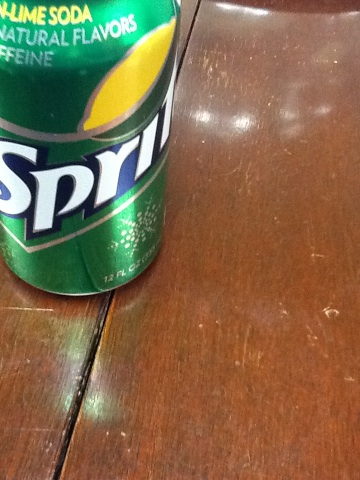What does the text on the can indicate about the product's features? The text on the can indicates that this Sprite is a lime-flavored soda with natural flavors. It also suggests an energizing aspect with the mention of caffeine, which is not commonly associated with Sprite, indicating a special or different formulation from the regular version. 